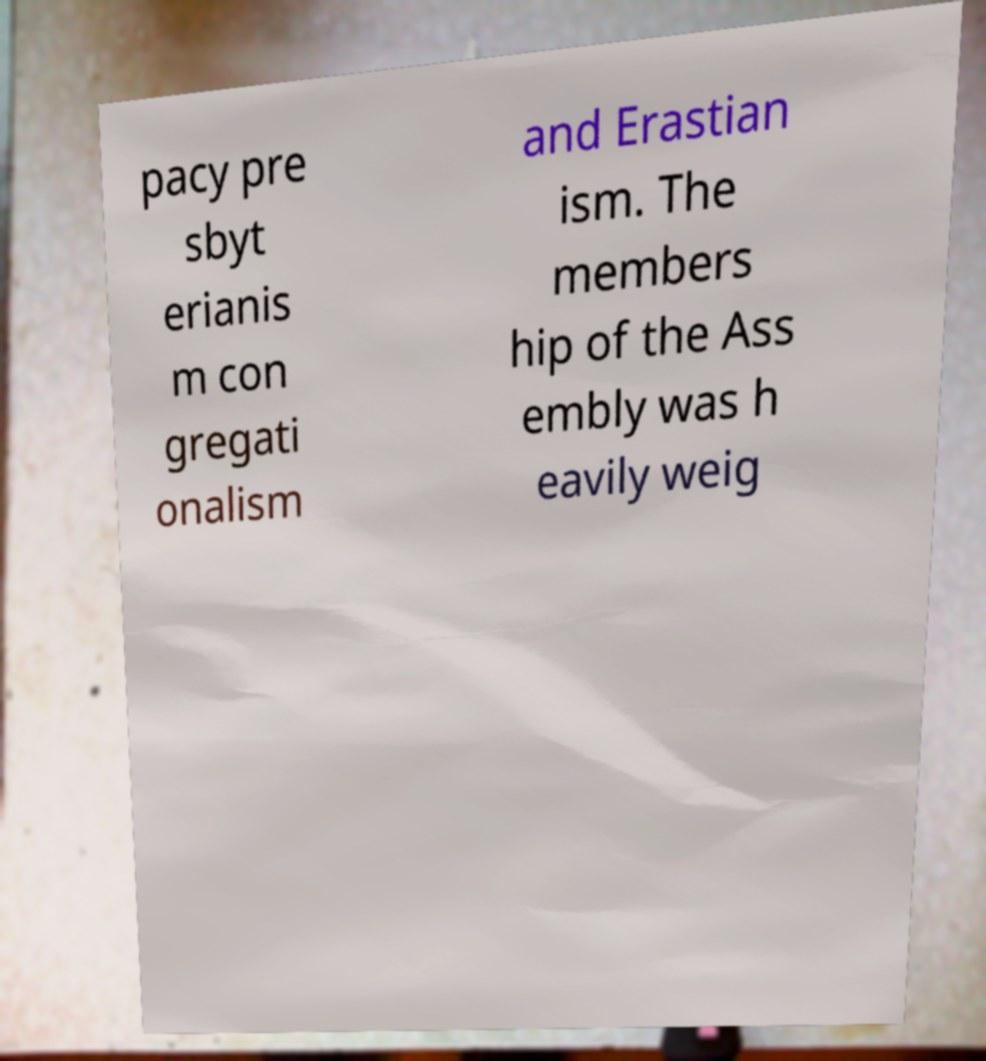Can you read and provide the text displayed in the image?This photo seems to have some interesting text. Can you extract and type it out for me? pacy pre sbyt erianis m con gregati onalism and Erastian ism. The members hip of the Ass embly was h eavily weig 